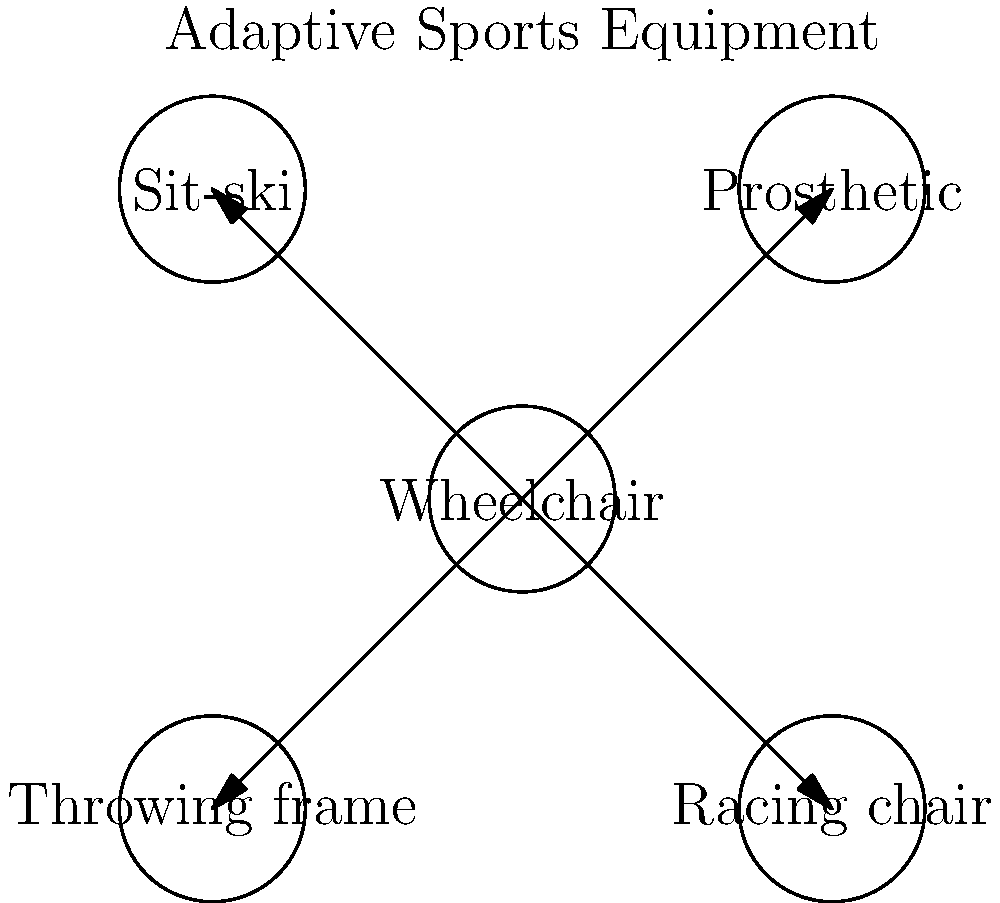In the network diagram of adaptive sports equipment, which piece of equipment is centrally connected to all others, reflecting its versatility across multiple Paralympic disciplines? To answer this question, let's analyze the network diagram step-by-step:

1. The diagram shows five pieces of adaptive sports equipment: Wheelchair, Prosthetic, Sit-ski, Racing chair, and Throwing frame.

2. Each piece of equipment is represented by a circle with its name inside.

3. The connections between the equipment are shown by arrows.

4. Looking at the connections, we can see that:
   a) The Wheelchair is connected to all other pieces of equipment.
   b) No other piece of equipment has connections to all others.

5. This central position of the Wheelchair in the network indicates its versatility and importance across various Paralympic disciplines.

6. The Wheelchair's connections to other equipment suggest that it can be modified or adapted for use in different sports, such as:
   - Wheelchair to Prosthetic: For athletes who use both
   - Wheelchair to Sit-ski: Adaptation for winter sports
   - Wheelchair to Racing chair: Specialized for racing events
   - Wheelchair to Throwing frame: Adaptation for field events

7. This central role of the Wheelchair aligns with the fact that many Paralympic sports have wheelchair versions, including basketball, tennis, rugby, and athletics.

Therefore, the piece of equipment centrally connected to all others, reflecting its versatility across multiple Paralympic disciplines, is the Wheelchair.
Answer: Wheelchair 